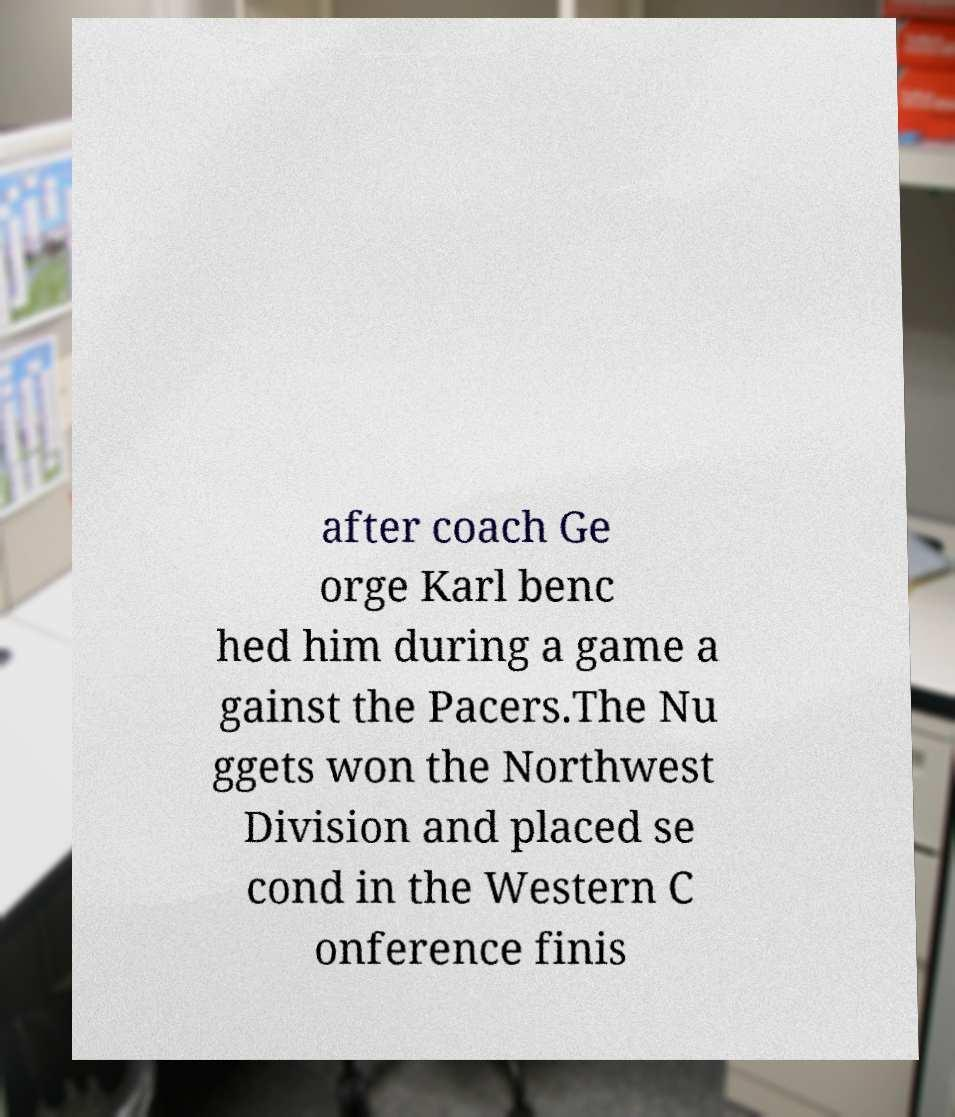Please identify and transcribe the text found in this image. after coach Ge orge Karl benc hed him during a game a gainst the Pacers.The Nu ggets won the Northwest Division and placed se cond in the Western C onference finis 